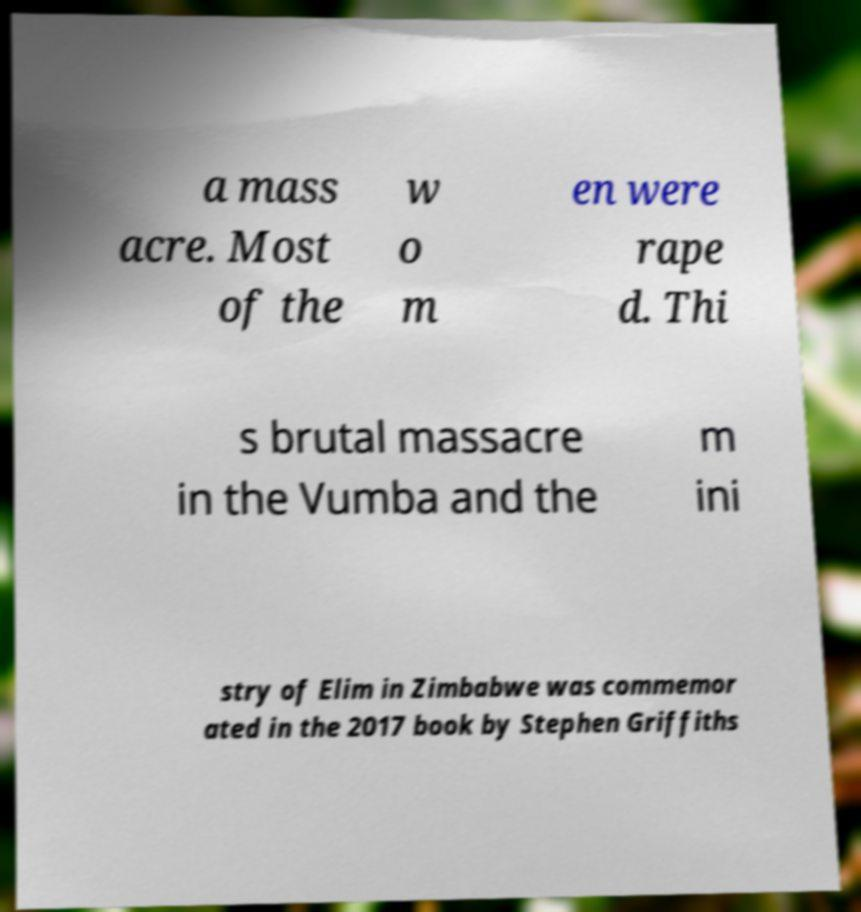For documentation purposes, I need the text within this image transcribed. Could you provide that? a mass acre. Most of the w o m en were rape d. Thi s brutal massacre in the Vumba and the m ini stry of Elim in Zimbabwe was commemor ated in the 2017 book by Stephen Griffiths 